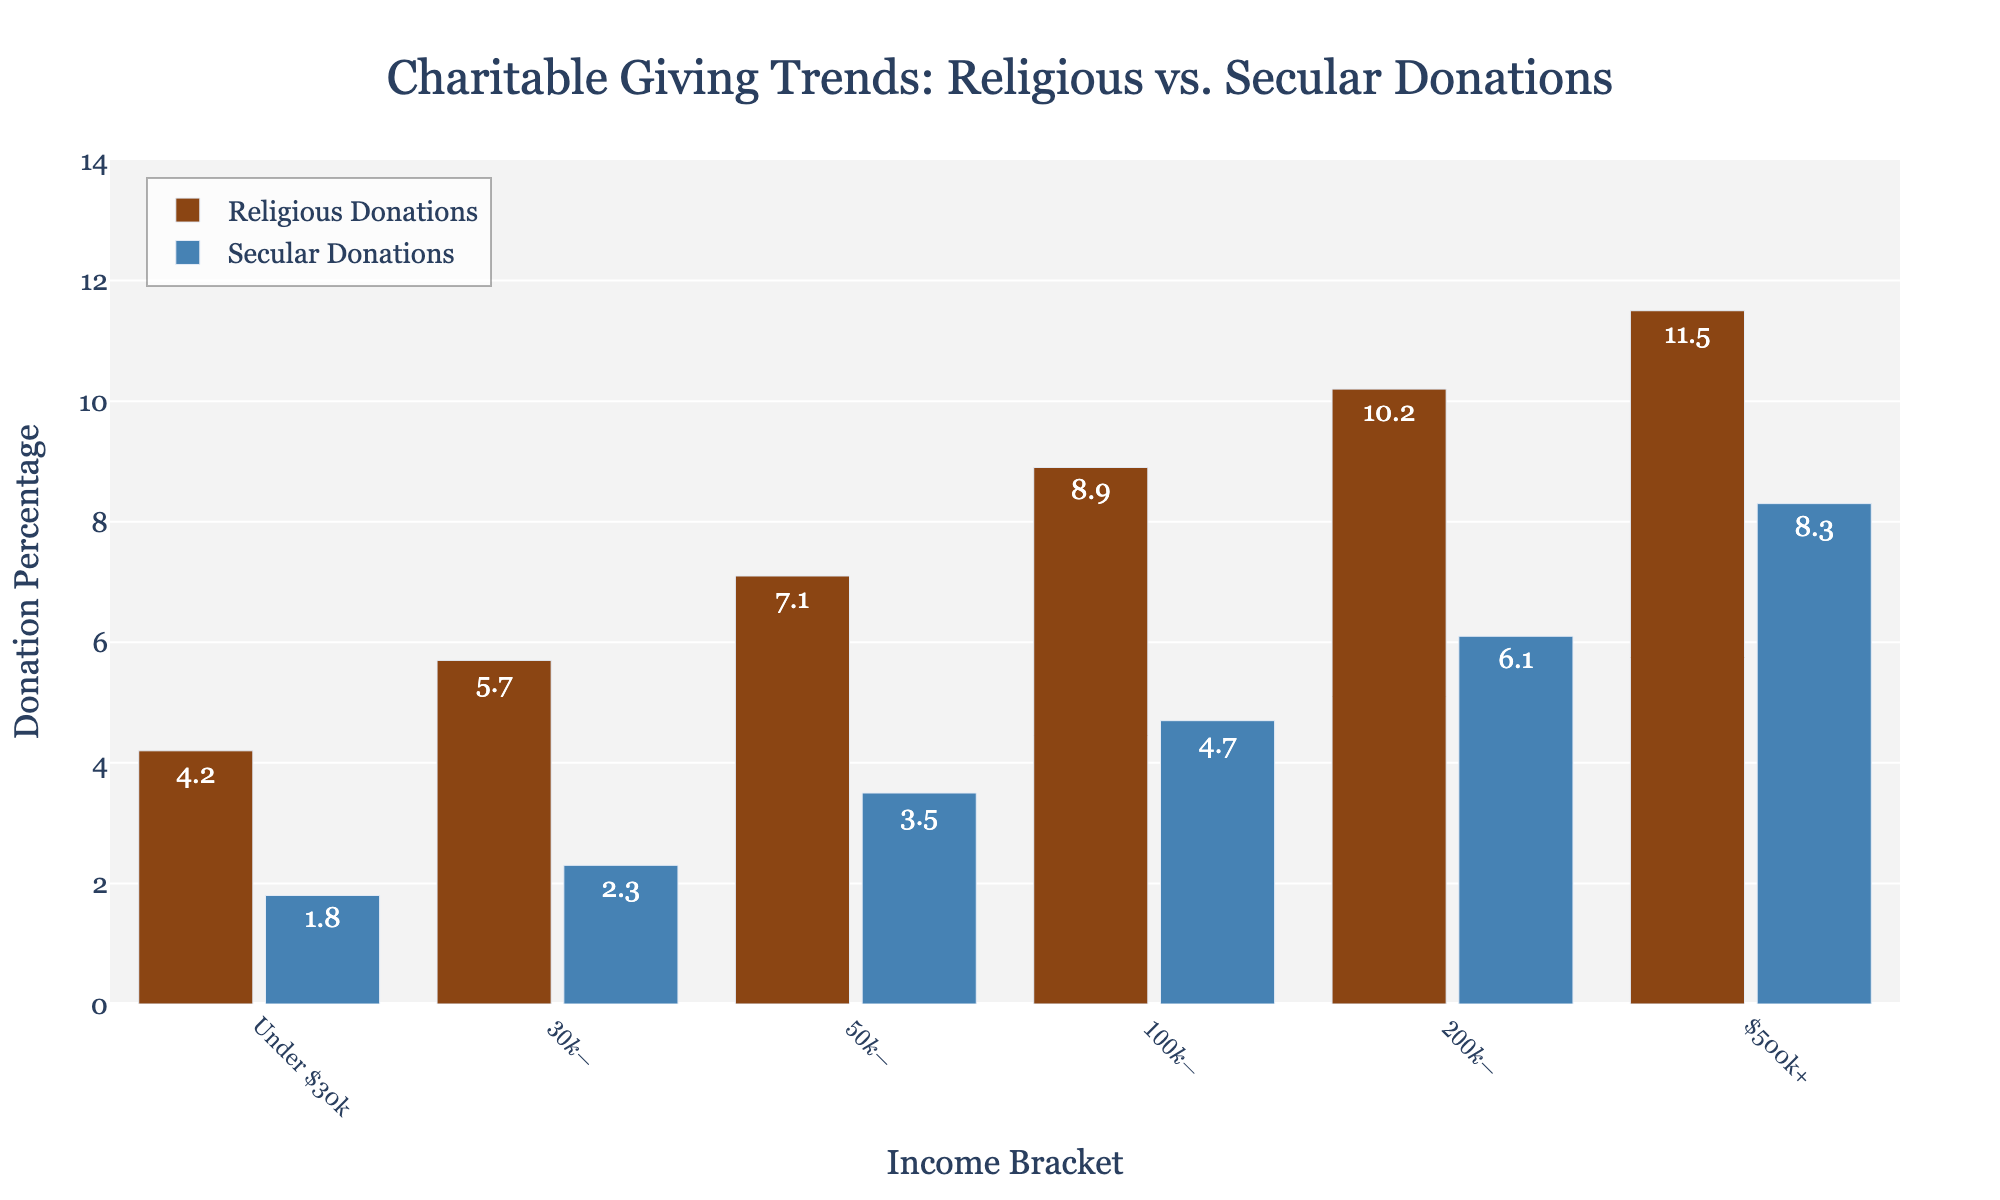What income bracket donates the most to religious causes? To find the income bracket that donates the most to religious causes, look for the highest bar in the "Religious Donations" category. The $500k+ income bracket has the tallest bar in this category, indicating the highest percentage of donations.
Answer: $500k+ Which income bracket donates more to secular causes: under $30k or $30k-$49.9k? Compare the heights of the bars for the "Secular Donations" category for both income brackets. The $30k-$49.9k income bracket has a higher bar (2.3%) compared to the under $30k income bracket (1.8%).
Answer: $30k-$49.9k How much more do individuals in the $200k-$499.9k bracket donate to religious compared to secular causes? Subtract the percentage of secular donations from the percentage of religious donations for the $200k-$499.9k bracket: 10.2 (religious) - 6.1 (secular) = 4.1.
Answer: 4.1% What's the average percentage of secular donations for all income brackets? Add up all the percentages for secular donations and divide by the number of income brackets: (1.8 + 2.3 + 3.5 + 4.7 + 6.1 + 8.3) / 6 = 26.7 / 6 ≈ 4.45.
Answer: 4.45% Which income bracket has a smaller gap between religious and secular donations: $50k-$99.9k or $100k-$199.9k? Calculate the gaps for both brackets by subtracting secular donations from religious donations. For $50k-$99.9k: 7.1 - 3.5 = 3.6. For $100k-$199.9k: 8.9 - 4.7 = 4.2. The $50k-$99.9k bracket has a smaller gap.
Answer: $50k-$99.9k What is the total percentage donated by individuals in the under $30k bracket (sum of religious and secular)? Add the religious and secular donations for the under $30k bracket: 4.2 (religious) + 1.8 (secular) = 6.0.
Answer: 6.0% What's the difference in secular donations between the $100k-$199.9k bracket and the $200k-$499.9k bracket? Subtract the secular donation percentage of the $100k-$199.9k bracket from that of the $200k-$499.9k bracket: 6.1 - 4.7 = 1.4.
Answer: 1.4% Do individuals with an income of $500k+ donate more to religious causes or secular causes? Compare the bars for the $500k+ income bracket in the religious and secular donations categories. The religious donations bar (11.5%) is taller than the secular donations bar (8.3%).
Answer: Religious causes 